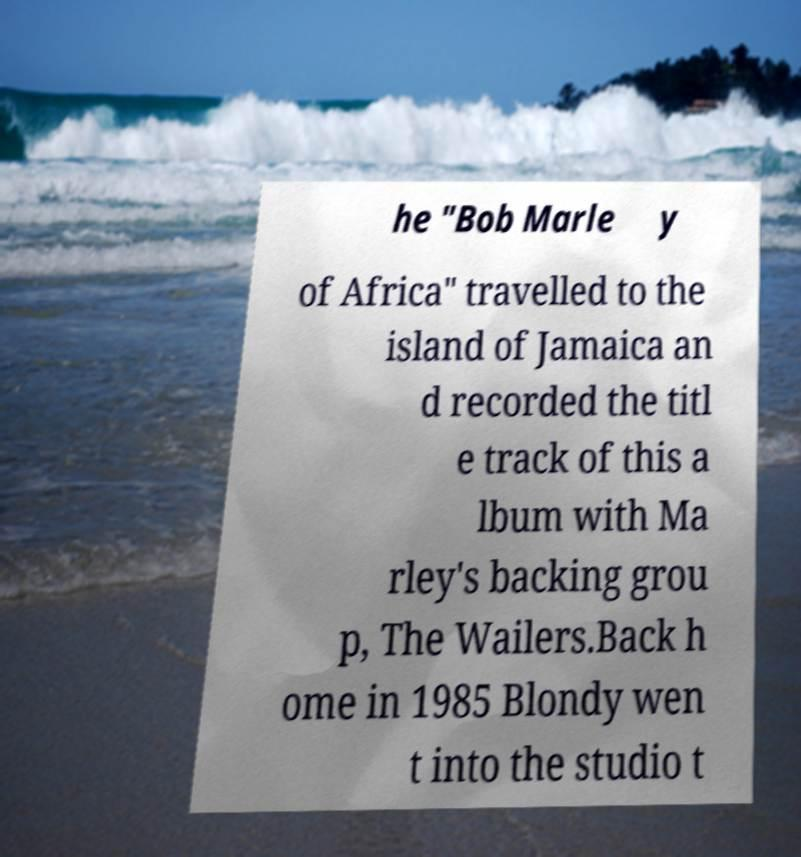There's text embedded in this image that I need extracted. Can you transcribe it verbatim? he "Bob Marle y of Africa" travelled to the island of Jamaica an d recorded the titl e track of this a lbum with Ma rley's backing grou p, The Wailers.Back h ome in 1985 Blondy wen t into the studio t 